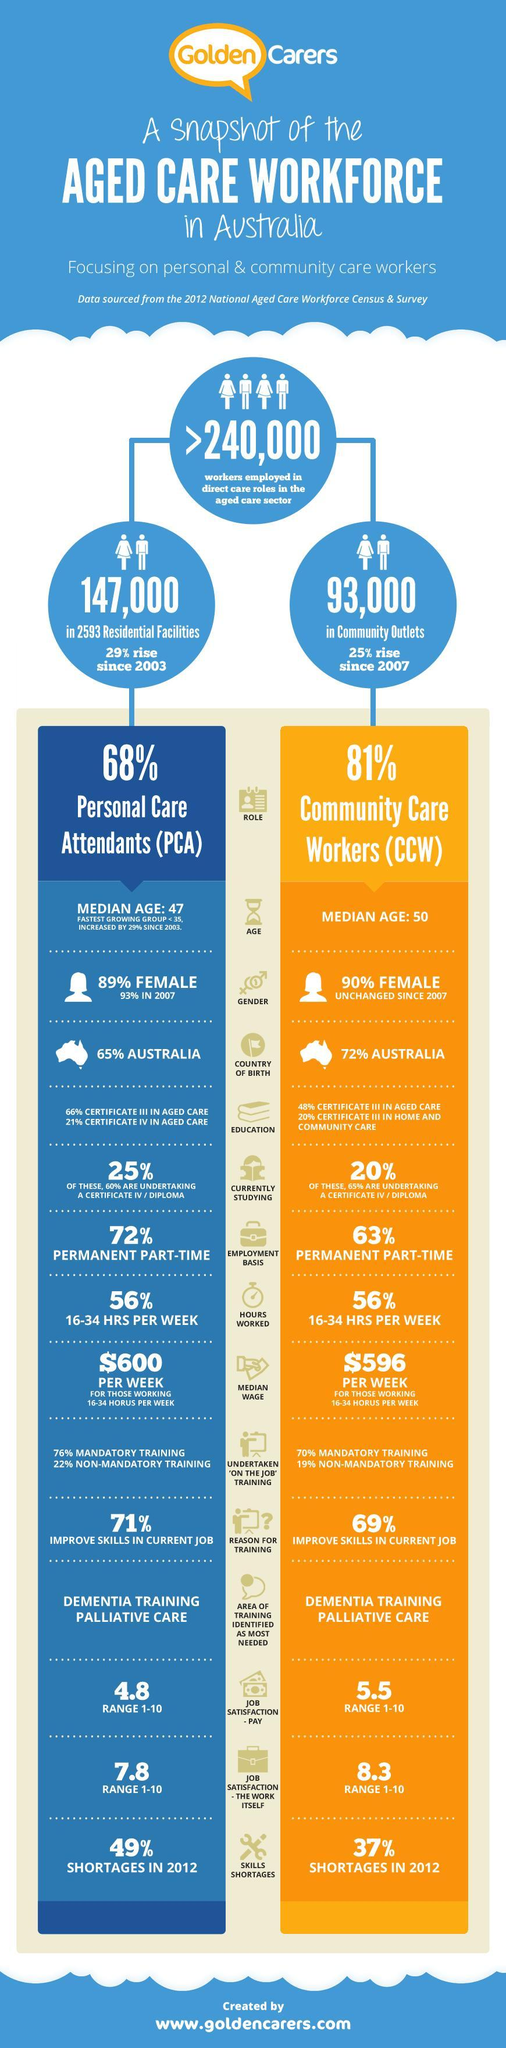What is the percentage of females who work as Community care workers?
Answer the question with a short phrase. 90% What is the percentage of rise in workers employed in direct care roles in the aged care sector in community outlets since 2007? 25% What is the percentage of rise in workers employed in direct care roles in the aged care sector in residential facilities since 2003? 29% What percentage have Certificate III in aged care in Community care workers? 48% What is the percentage of skill shortage in Personal care assistants in 2012? 49% What percentage have Australia as Country of birth in Community care workers? 72% What percentage of hours worked by 81% of Community care workers? 56% What percentage have Australia as Country of birth in Personal Care Attendants? 65% What percentage of hours worked by 68% of Personal Care Attendants? 56% What percentage have Certificate III in aged care in Personal care assistants? 66% 